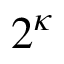<formula> <loc_0><loc_0><loc_500><loc_500>2 ^ { \kappa }</formula> 